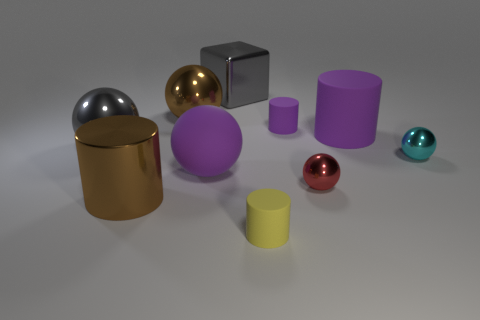Subtract all shiny spheres. How many spheres are left? 1 Subtract all purple balls. How many balls are left? 4 Subtract all blocks. How many objects are left? 9 Subtract 3 spheres. How many spheres are left? 2 Subtract all cyan balls. Subtract all yellow cylinders. How many balls are left? 4 Subtract all red blocks. How many red balls are left? 1 Subtract all brown metal cylinders. Subtract all small purple cylinders. How many objects are left? 8 Add 2 purple things. How many purple things are left? 5 Add 7 tiny green shiny things. How many tiny green shiny things exist? 7 Subtract 2 purple cylinders. How many objects are left? 8 